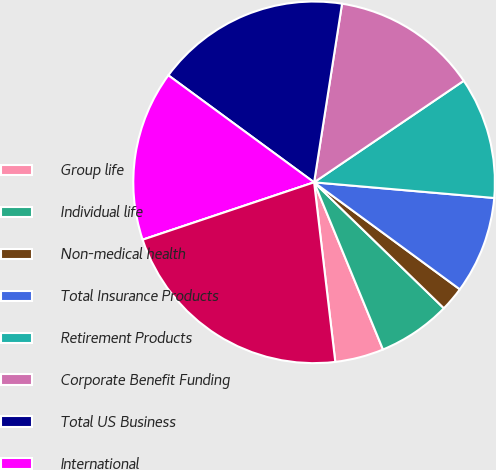Convert chart to OTSL. <chart><loc_0><loc_0><loc_500><loc_500><pie_chart><fcel>Group life<fcel>Individual life<fcel>Non-medical health<fcel>Total Insurance Products<fcel>Retirement Products<fcel>Corporate Benefit Funding<fcel>Total US Business<fcel>International<fcel>Banking Corporate & Other<fcel>Total<nl><fcel>4.35%<fcel>6.52%<fcel>2.18%<fcel>8.7%<fcel>10.87%<fcel>13.04%<fcel>17.39%<fcel>15.22%<fcel>0.0%<fcel>21.73%<nl></chart> 